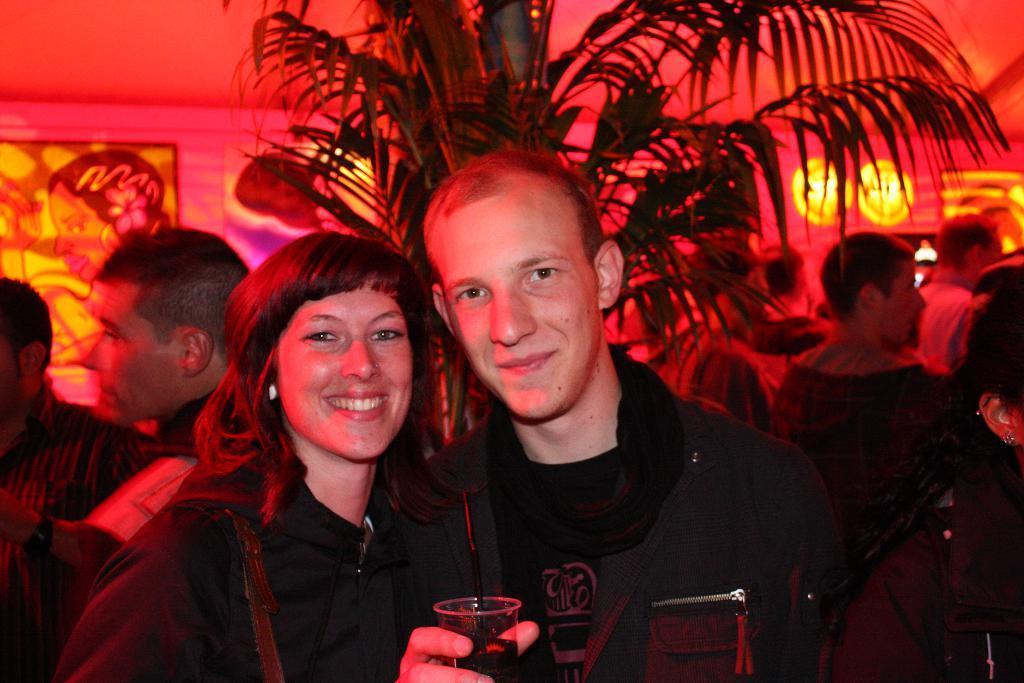Describe this image in one or two sentences. In the middle of the image we can see two persons and they are smiling. He is holding a glass with his hand. In the background we can see people, tree, lights, frame, wall, and few objects. 